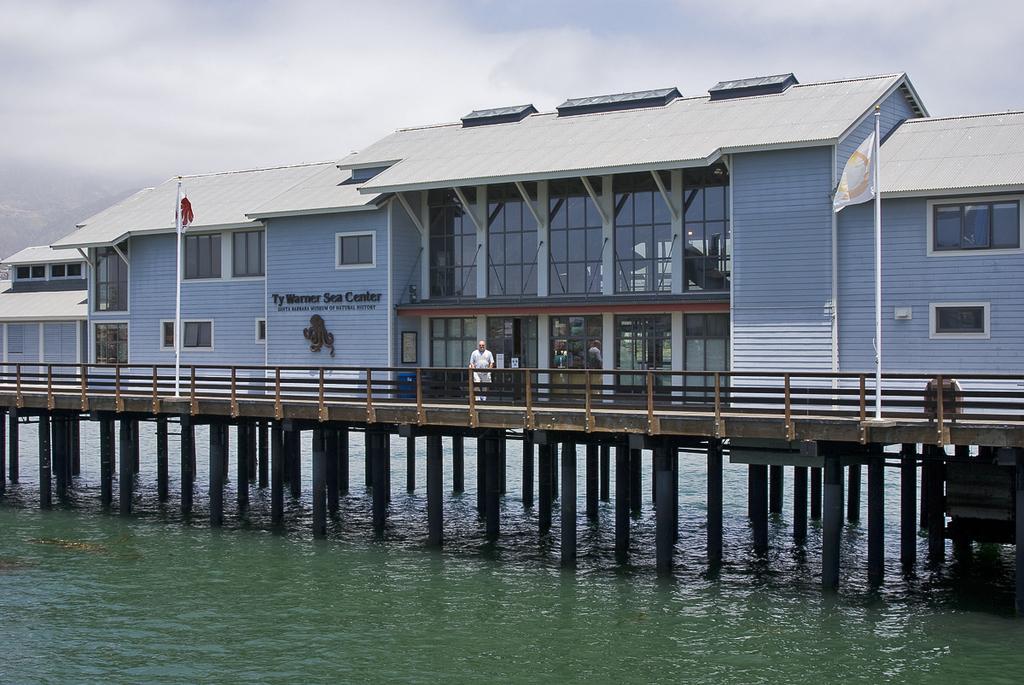Please provide a concise description of this image. In this picture there are buildings and there is text on the wall. In the foreground there is a man standing behind the railing and there are flags. At the top there is sky and there are clouds. At the bottom there is water. On the left side of the image it looks like a mountain. 